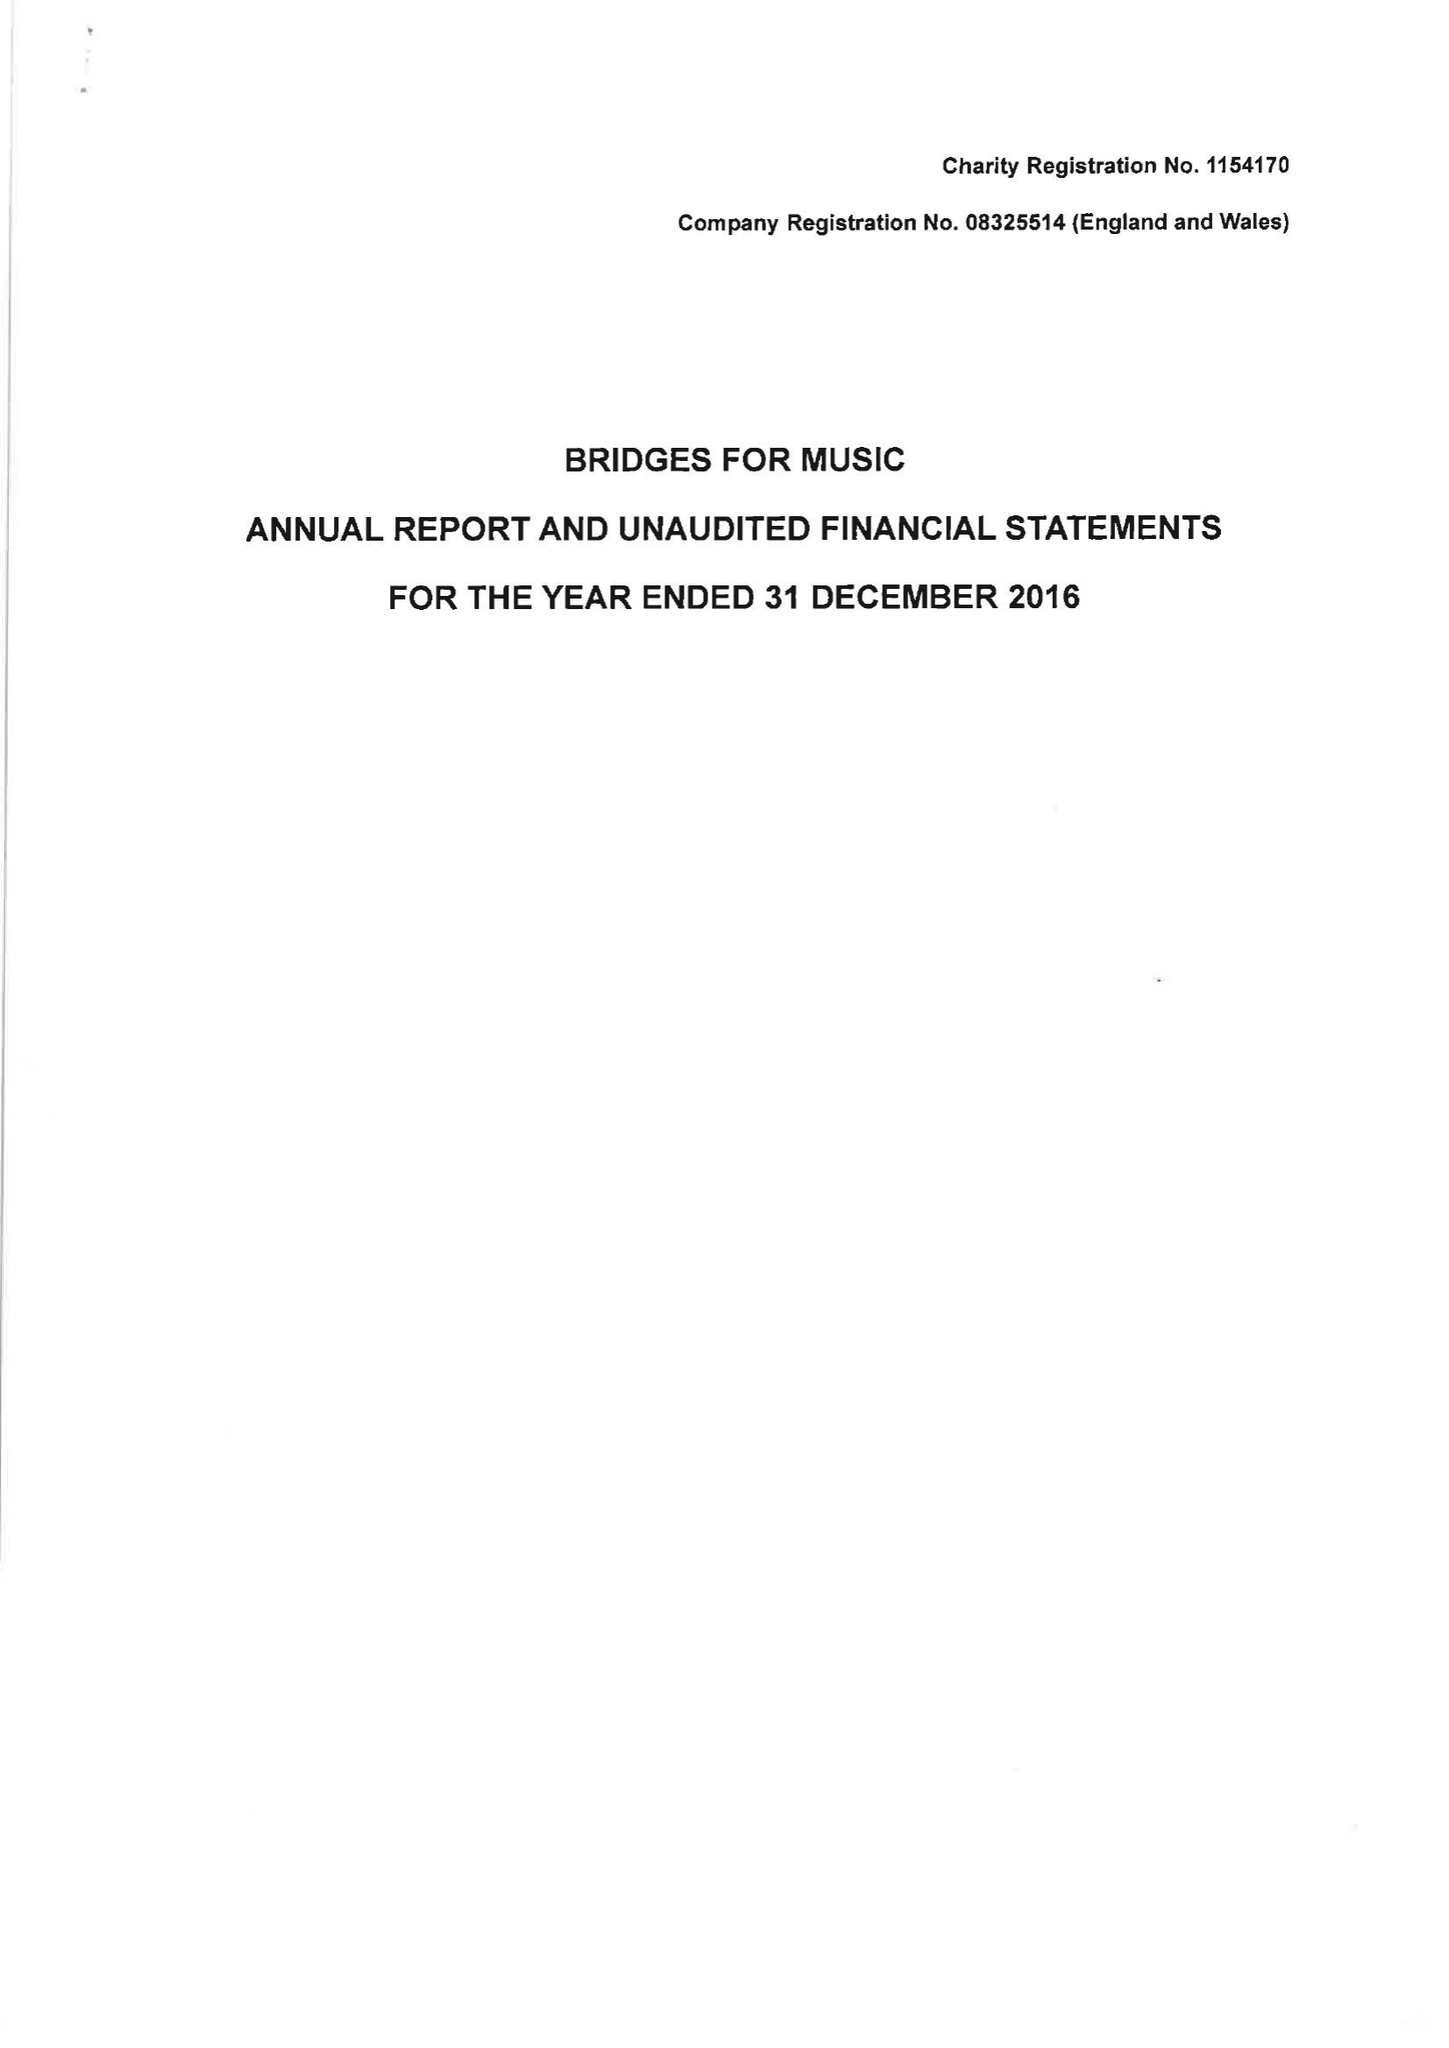What is the value for the report_date?
Answer the question using a single word or phrase. 2016-12-31 